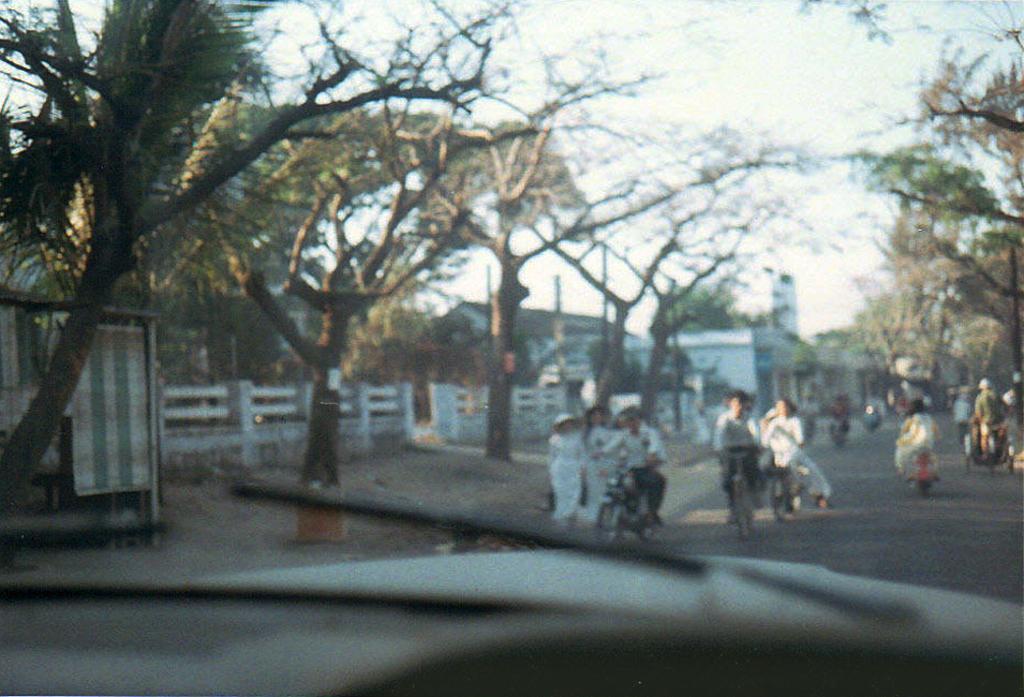Please provide a concise description of this image. In this image we can see the windscreen of a vehicle. Through the windscreen we can see few persons are riding vehicles and bicycles on the road and there are few persons walking on the road and we can see trees, fence, buildings, poles and sky. 